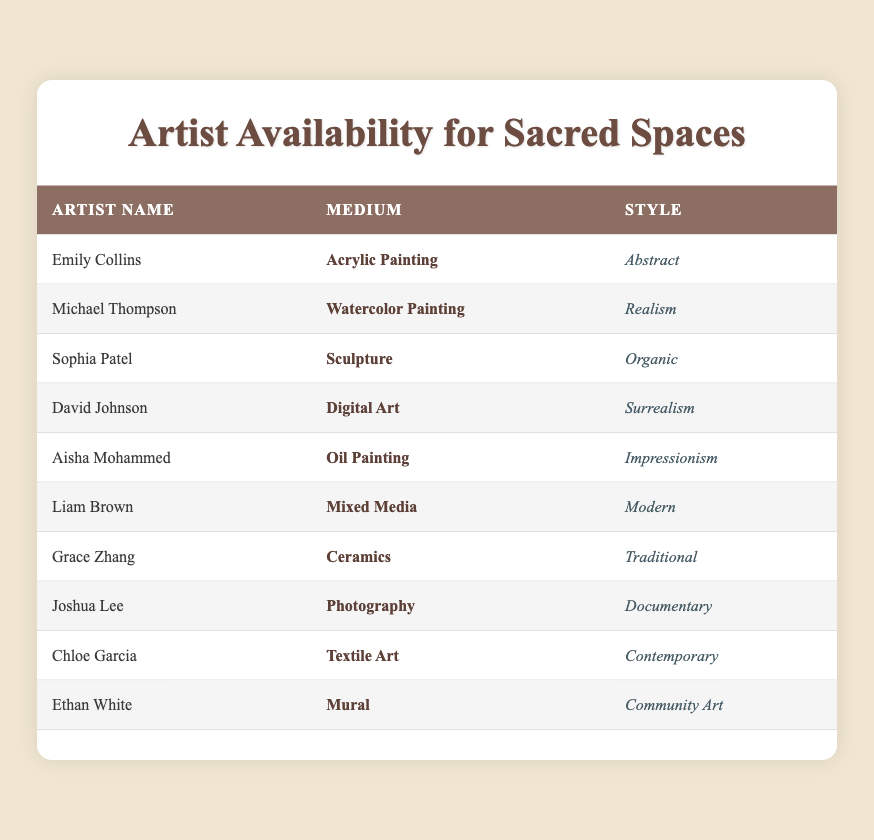What is the primary medium used by Sophia Patel? Sophia Patel's record in the table states that her medium is "Sculpture"
Answer: Sculpture How many artists use Acrylic Painting as their medium? The table shows only one artist, Emily Collins, as using Acrylic Painting.
Answer: 1 Is there any artist who uses Mural as their medium? Yes, Ethan White is listed in the table as using Mural for his medium.
Answer: Yes What is the style of the artist using Oil Painting? The table indicates that Aisha Mohammed, who uses Oil Painting, has the style "Impressionism".
Answer: Impressionism Calculate the total number of artists with a style that falls under modern or contemporary. The table lists Liam Brown with "Modern" and Chloe Garcia with "Contemporary". This gives a total of 2 artists whose styles fall under those categories.
Answer: 2 Which medium has the highest number of artists? There is one artist for each medium listed in the table, resulting in no medium having a higher representation than others.
Answer: None What is the style of the artist who uses Digital Art? According to the table, David Johnson is the artist using Digital Art, and his style is "Surrealism".
Answer: Surrealism Are there more artists who use Traditional style than those who use Abstract style? The table shows that there is one artist (Grace Zhang) using Traditional and one artist (Emily Collins) using Abstract; hence, they are equal.
Answer: No How many different mediums are represented in the table? By examining the table, there are 10 unique entries under the Medium column, each corresponding to a different artist.
Answer: 10 Which artist does not have a contemporary style? The table lists multiple artists and identifies Chloe Garcia as the only artist with "Contemporary" style; thus, all others do not belong to this category.
Answer: All except Chloe Garcia 